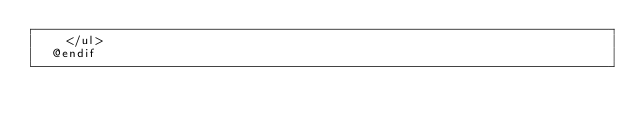<code> <loc_0><loc_0><loc_500><loc_500><_PHP_>		</ul>
	@endif</code> 